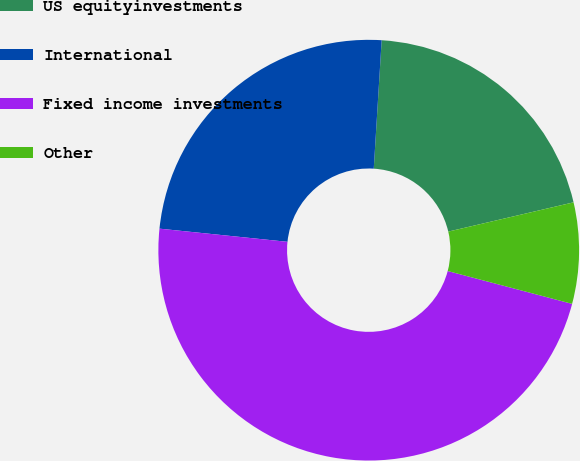Convert chart. <chart><loc_0><loc_0><loc_500><loc_500><pie_chart><fcel>US equityinvestments<fcel>International<fcel>Fixed income investments<fcel>Other<nl><fcel>20.37%<fcel>24.35%<fcel>47.53%<fcel>7.76%<nl></chart> 